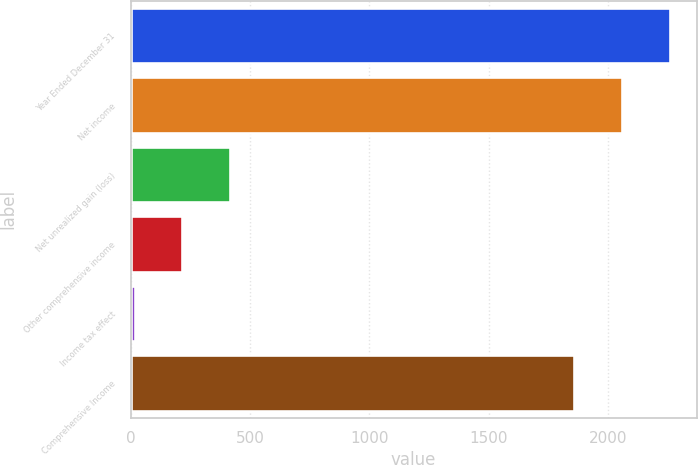<chart> <loc_0><loc_0><loc_500><loc_500><bar_chart><fcel>Year Ended December 31<fcel>Net income<fcel>Net unrealized gain (loss)<fcel>Other comprehensive income<fcel>Income tax effect<fcel>Comprehensive Income<nl><fcel>2259.6<fcel>2059.8<fcel>417.6<fcel>217.8<fcel>18<fcel>1860<nl></chart> 